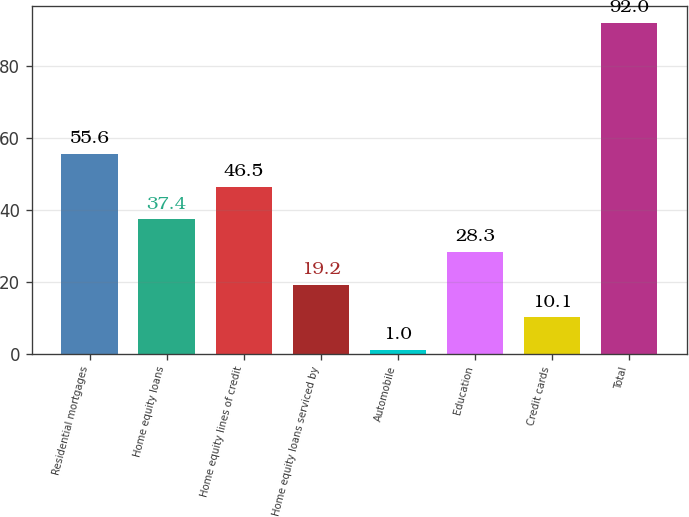Convert chart to OTSL. <chart><loc_0><loc_0><loc_500><loc_500><bar_chart><fcel>Residential mortgages<fcel>Home equity loans<fcel>Home equity lines of credit<fcel>Home equity loans serviced by<fcel>Automobile<fcel>Education<fcel>Credit cards<fcel>Total<nl><fcel>55.6<fcel>37.4<fcel>46.5<fcel>19.2<fcel>1<fcel>28.3<fcel>10.1<fcel>92<nl></chart> 